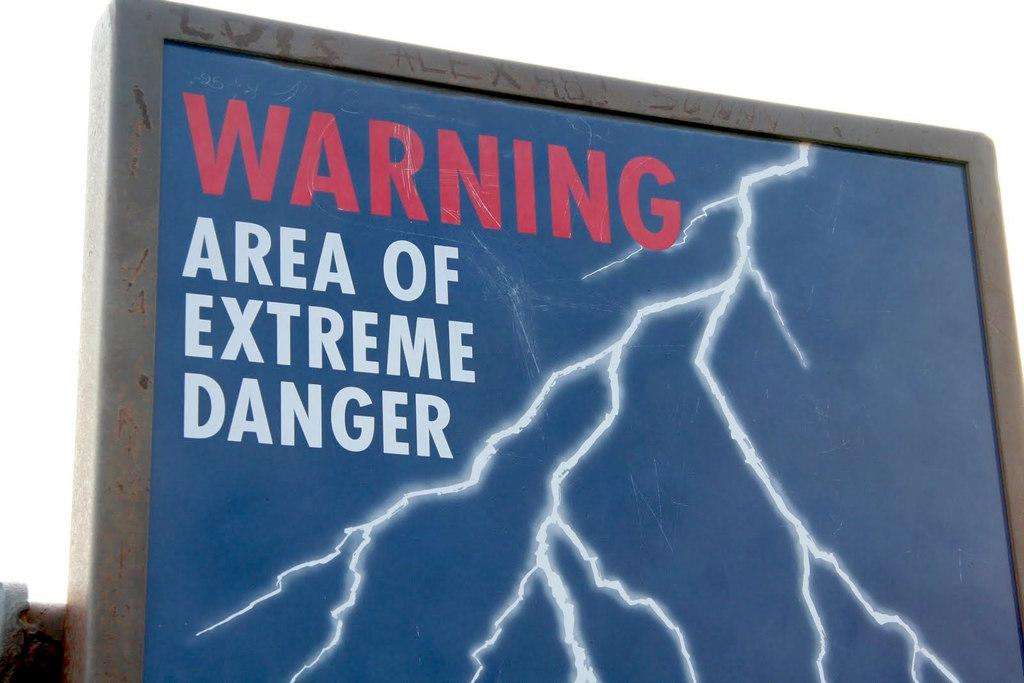<image>
Provide a brief description of the given image. A sign offers a warning of lightning danger. 